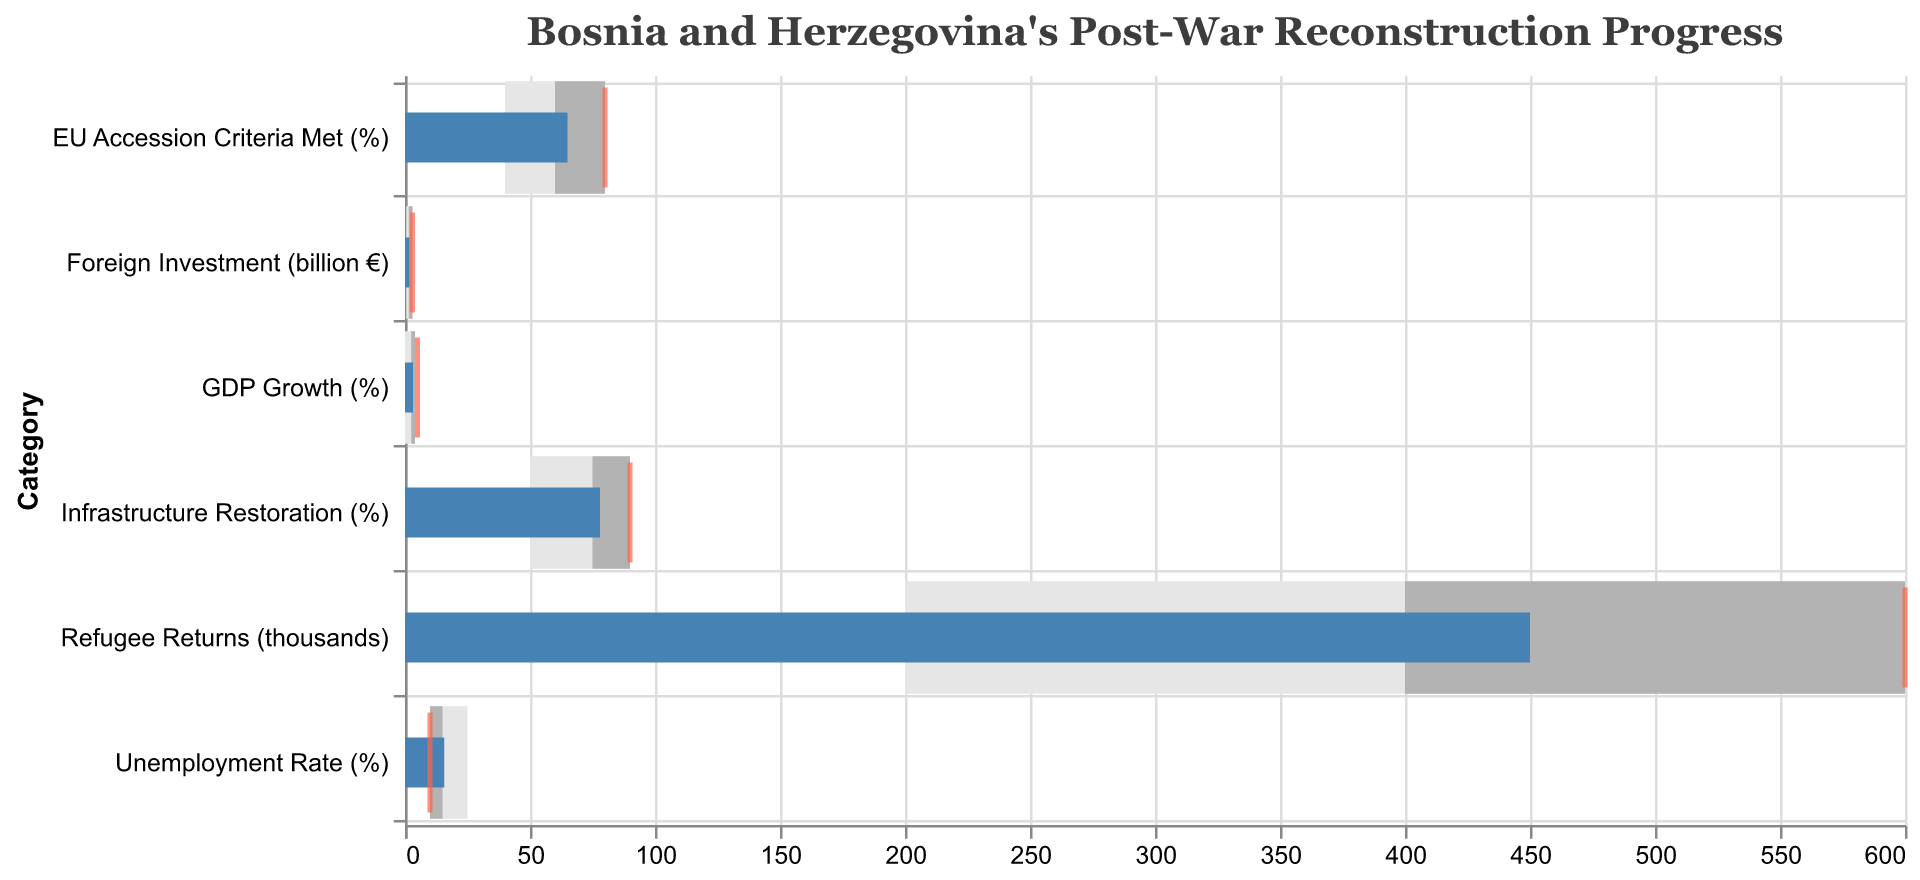How many categories are displayed in the figure? There are 6 categories listed: GDP Growth (%), Unemployment Rate (%), Refugee Returns (thousands), Infrastructure Restoration (%), Foreign Investment (billion €), and EU Accession Criteria Met (%).
Answer: 6 What is the target for the Foreign Investment category? The target for Foreign Investment is represented by the tick mark, which is at the value of 3.0 billion €.
Answer: 3.0 billion € How much more is required for GDP Growth (%) to meet its target? The target GDP Growth is 5.0%, and the actual value is 3.2%. Subtracting the actual value from the target: 5.0 - 3.2 = 1.8%.
Answer: 1.8% Which category has the closest actual value to its target? Comparing the actual values and targets, the closest is Refugee Returns, with an actual value of 450 thousands and a target of 600 thousands. The difference is 150, which is less than for other categories.
Answer: Refugee Returns Is the Unemployment Rate within the 'Average' range? The 'Average' range for Unemployment Rate is between 15% and 10%. The actual Unemployment Rate is 15.7%, which is above the 'Average' range.
Answer: No How many categories have actual values classified as 'Good'? The 'Good' range for each category is specified. The only category with an actual value falling within the 'Good' range is Infrastructure Restoration (78% within the 75-90% range).
Answer: 1 Which category has the largest gap between its 'Poor' and 'Good' ranges? Examining the 'Poor' and 'Good' ranges for each category, EU Accession Criteria Met (%) has a gap of 40% (40% to 80%) which is the largest gap among the categories.
Answer: EU Accession Criteria Met (%) What is the average target value of all categories? Targets are 5.0%, 10.0%, 600 thousands, 90%, 3.0 billion €, and 80%. The sum is (5.0 + 10.0 + 600 + 90 + 3.0 + 80) = 788. The average is 788 / 6 = 131.33 (non-normalized across mixed units).
Answer: 131.33 (mixed units) How does the actual Foreign Investment compare to the 'Average' range? The 'Average' range for Foreign Investment is between 1.5 billion € and 3.0 billion €. The actual value is 1.8 billion €, which is within the 'Average' range.
Answer: Within 'Average' 